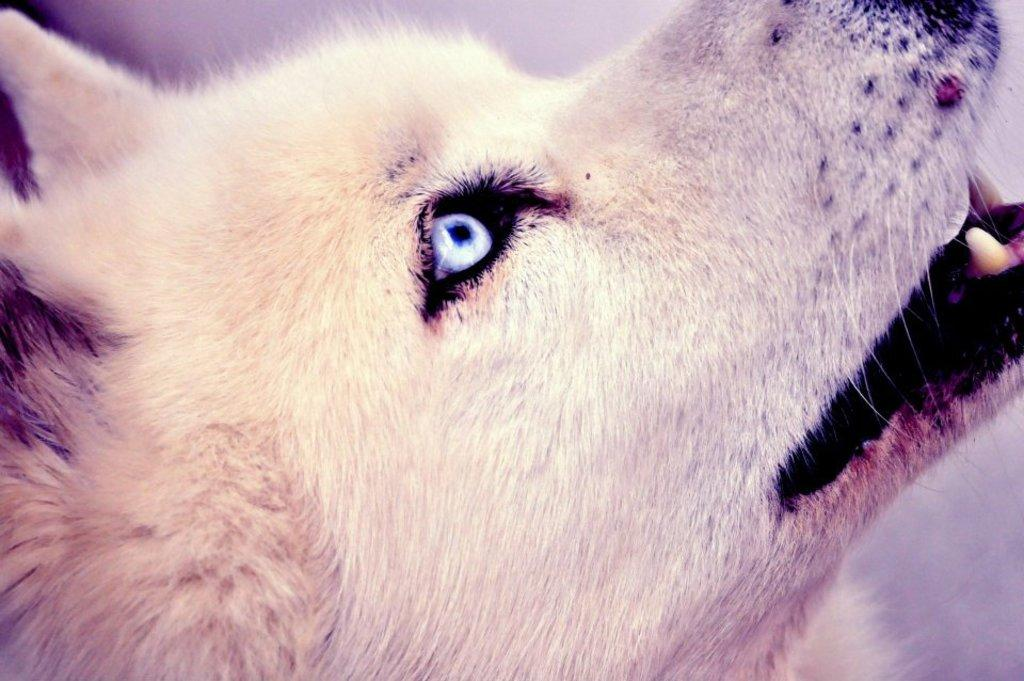What animal is present in the picture? There is a dog in the picture. How is the dog's face positioned in the image? The dog's face is shown from the side view. What is the dog doing in the image? The dog is looking up. What color is the dog's hair? The dog has cream-colored hair. What does the caption on the picture say about the men in the hall? There is no caption present in the image, and no men or hall are mentioned in the provided facts. 